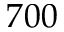<formula> <loc_0><loc_0><loc_500><loc_500>7 0 0</formula> 